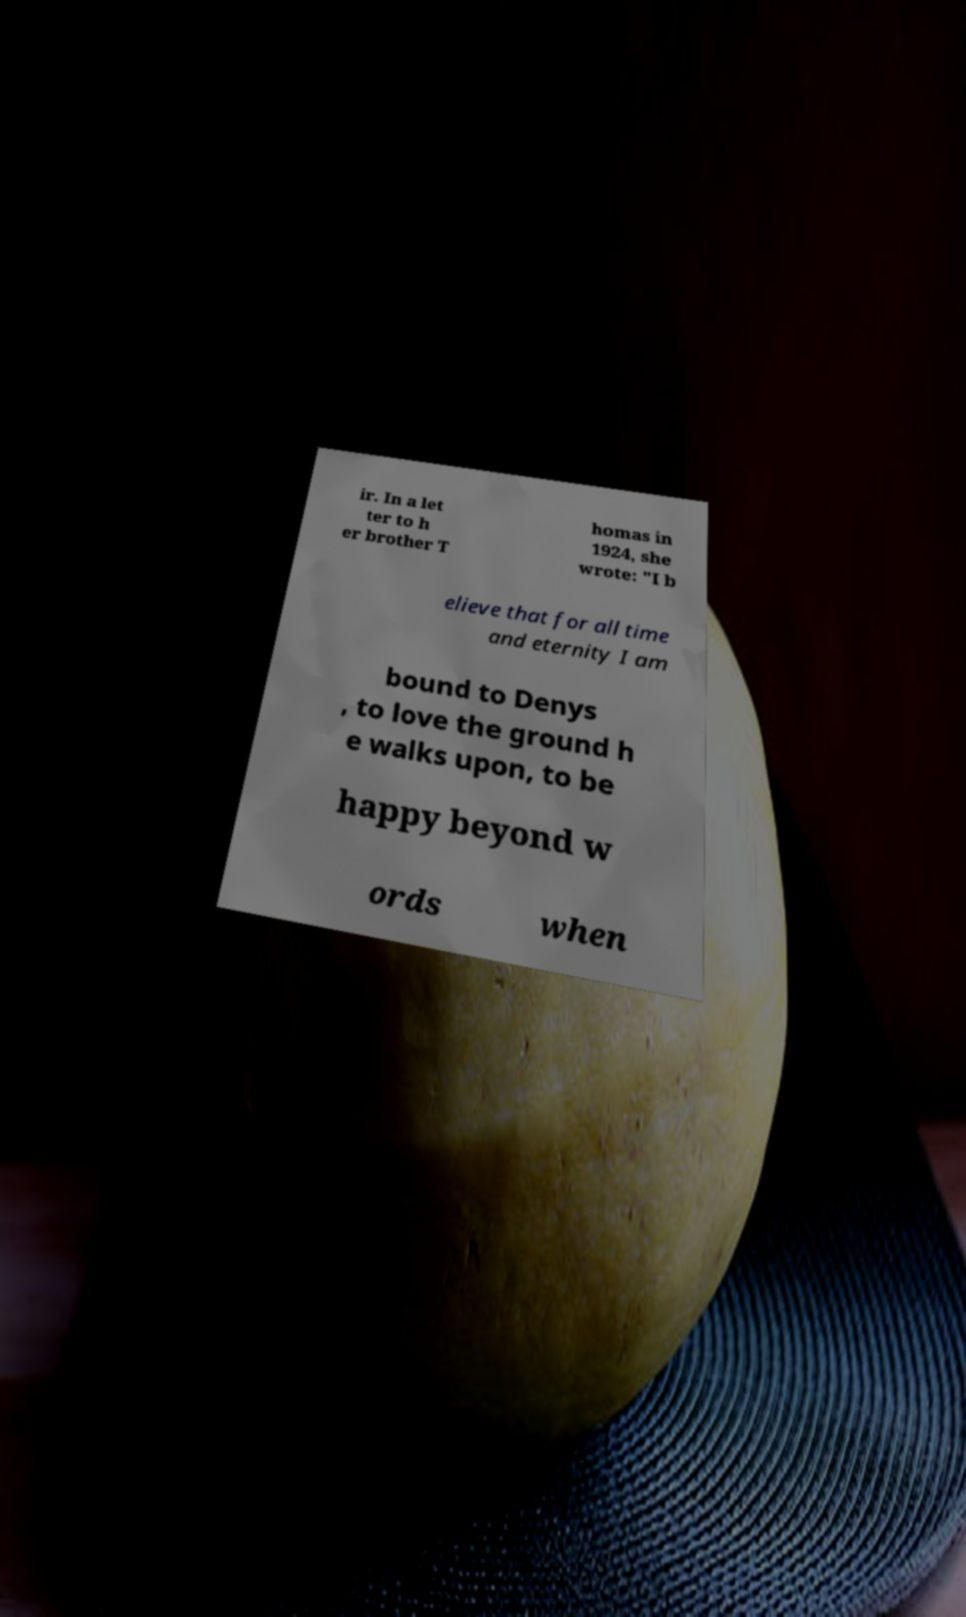Please read and relay the text visible in this image. What does it say? ir. In a let ter to h er brother T homas in 1924, she wrote: "I b elieve that for all time and eternity I am bound to Denys , to love the ground h e walks upon, to be happy beyond w ords when 